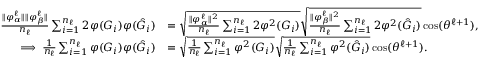Convert formula to latex. <formula><loc_0><loc_0><loc_500><loc_500>\begin{array} { r l } { \frac { \| { { \varphi } _ { \alpha } ^ { \ell } } \| \| { { \varphi } _ { \beta } ^ { \ell } } \| } { n _ { \ell } } \sum _ { i = 1 } ^ { n _ { \ell } } 2 { \varphi } ( G _ { i } ) { \varphi } ( \hat { G } _ { i } ) } & { = \sqrt { \frac { \| { { \varphi } _ { \alpha } ^ { \ell } } \| ^ { 2 } } { n _ { \ell } } \sum _ { i = 1 } ^ { n _ { \ell } } 2 { \varphi } ^ { 2 } ( G _ { i } ) } \sqrt { \frac { \| { { \varphi } _ { \beta } ^ { \ell } } \| ^ { 2 } } { n _ { \ell } } \sum _ { i = 1 } ^ { n _ { \ell } } 2 { \varphi } ^ { 2 } ( \hat { G } _ { i } ) } \cos ( \theta ^ { \ell + 1 } ) , } \\ { \implies \frac { 1 } { n _ { \ell } } \sum _ { i = 1 } ^ { n _ { \ell } } { \varphi } ( G _ { i } ) { \varphi } ( \hat { G } _ { i } ) } & { = \sqrt { \frac { 1 } { n _ { \ell } } \sum _ { i = 1 } ^ { n _ { \ell } } { \varphi } ^ { 2 } ( G _ { i } ) } \sqrt { \frac { 1 } { n _ { \ell } } \sum _ { i = 1 } ^ { n _ { \ell } } { \varphi } ^ { 2 } ( \hat { G } _ { i } ) } \cos ( \theta ^ { \ell + 1 } ) . } \end{array}</formula> 